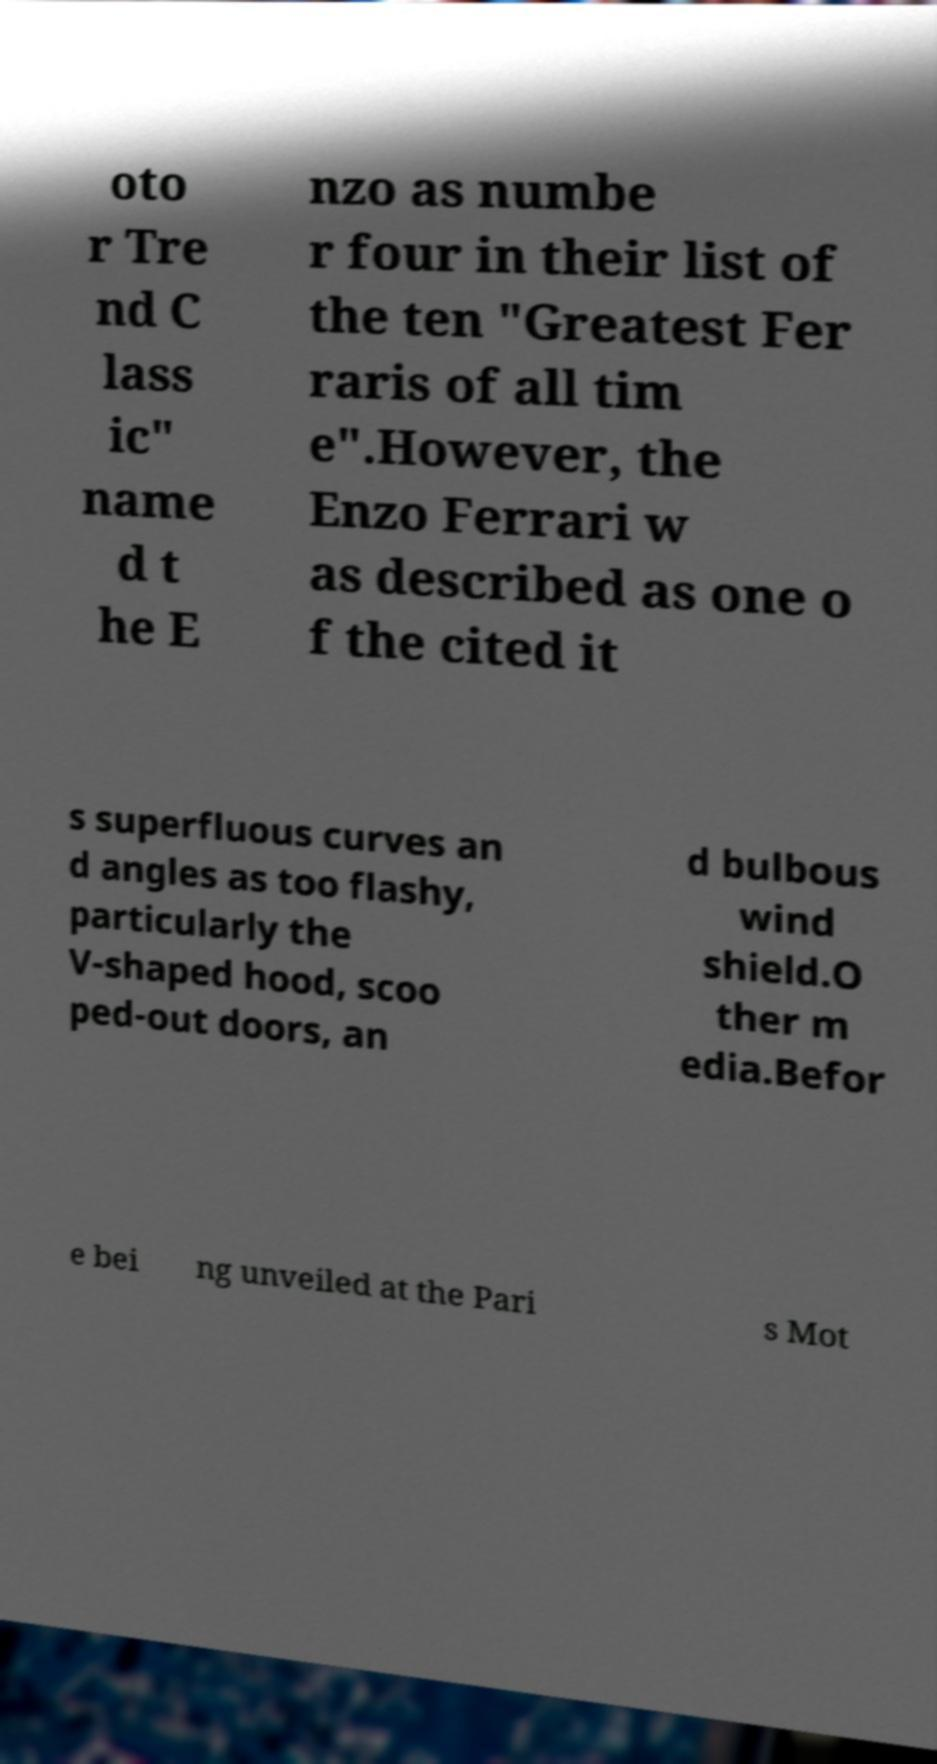I need the written content from this picture converted into text. Can you do that? oto r Tre nd C lass ic" name d t he E nzo as numbe r four in their list of the ten "Greatest Fer raris of all tim e".However, the Enzo Ferrari w as described as one o f the cited it s superfluous curves an d angles as too flashy, particularly the V-shaped hood, scoo ped-out doors, an d bulbous wind shield.O ther m edia.Befor e bei ng unveiled at the Pari s Mot 